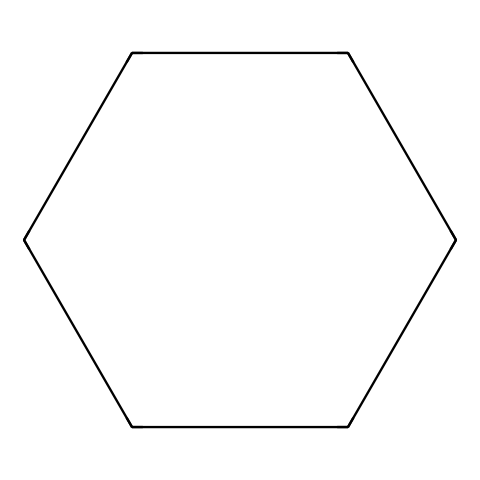What is the chemical name of this compound? The SMILES representation C1CCCCC1 indicates a six-membered carbon ring, which corresponds to cyclohexane in chemical nomenclature.
Answer: cyclohexane How many carbon atoms are in the structure? The structure reveals a cyclic arrangement of six carbon atoms forming a ring, which indicates there are six carbon atoms present.
Answer: 6 What type of bonding is present in this structure? The bonds between the carbon atoms in this cycloalkane are all single (sigma) bonds, characteristic of saturated hydrocarbons like cyclohexane.
Answer: single bonds Is this compound saturated or unsaturated? The presence of only single bonds among carbon atoms implies that the compound has the maximum number of hydrogen atoms bonded, which classifies it as saturated.
Answer: saturated What is the molecular formula of this compound? Given that there are six carbon atoms (C) and that saturated hydrocarbons follow the formula CnH2n, substituting n with 6 gives C6H12.
Answer: C6H12 What is the predicted state of this compound at room temperature? Cyclohexane, being a small molecular weight cycloalkane, is typically a liquid at room temperature due to its physical properties and boiling point.
Answer: liquid How does the structure of cycloalkanes affect their reactivity? Cycloalkanes like cyclohexane are relatively stable due to their saturated nature, which leads to lesser reactivity compared to unsaturated hydrocarbons like alkenes or alkynes.
Answer: lower reactivity 